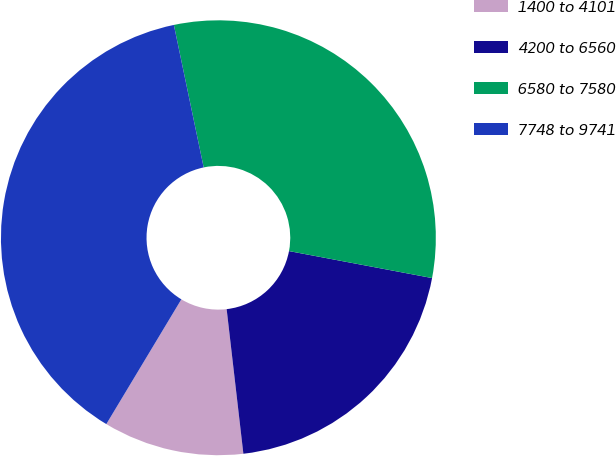<chart> <loc_0><loc_0><loc_500><loc_500><pie_chart><fcel>1400 to 4101<fcel>4200 to 6560<fcel>6580 to 7580<fcel>7748 to 9741<nl><fcel>10.45%<fcel>20.2%<fcel>31.25%<fcel>38.1%<nl></chart> 